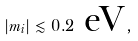Convert formula to latex. <formula><loc_0><loc_0><loc_500><loc_500>| m _ { i } | \lesssim 0 . 2 \text { eV} \, ,</formula> 